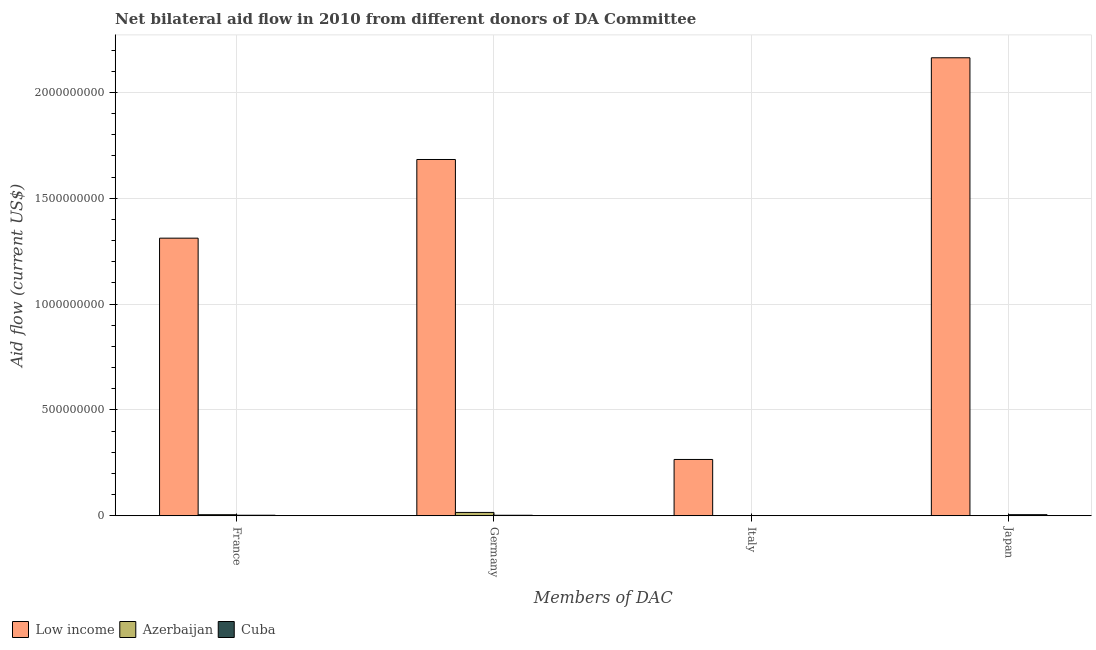How many groups of bars are there?
Your response must be concise. 4. Are the number of bars on each tick of the X-axis equal?
Provide a short and direct response. No. What is the amount of aid given by japan in Low income?
Keep it short and to the point. 2.16e+09. Across all countries, what is the maximum amount of aid given by japan?
Make the answer very short. 2.16e+09. Across all countries, what is the minimum amount of aid given by germany?
Give a very brief answer. 2.52e+06. In which country was the amount of aid given by italy maximum?
Your answer should be very brief. Low income. What is the total amount of aid given by germany in the graph?
Provide a short and direct response. 1.70e+09. What is the difference between the amount of aid given by germany in Low income and that in Azerbaijan?
Give a very brief answer. 1.67e+09. What is the difference between the amount of aid given by italy in Cuba and the amount of aid given by germany in Low income?
Provide a short and direct response. -1.68e+09. What is the average amount of aid given by japan per country?
Provide a succinct answer. 7.23e+08. What is the difference between the amount of aid given by italy and amount of aid given by japan in Cuba?
Provide a succinct answer. -4.27e+06. What is the ratio of the amount of aid given by italy in Cuba to that in Low income?
Keep it short and to the point. 0. Is the amount of aid given by germany in Cuba less than that in Azerbaijan?
Keep it short and to the point. Yes. What is the difference between the highest and the second highest amount of aid given by italy?
Keep it short and to the point. 2.65e+08. What is the difference between the highest and the lowest amount of aid given by japan?
Make the answer very short. 2.16e+09. In how many countries, is the amount of aid given by germany greater than the average amount of aid given by germany taken over all countries?
Make the answer very short. 1. Is the sum of the amount of aid given by germany in Low income and Cuba greater than the maximum amount of aid given by japan across all countries?
Give a very brief answer. No. Are all the bars in the graph horizontal?
Keep it short and to the point. No. How many countries are there in the graph?
Provide a succinct answer. 3. Does the graph contain any zero values?
Offer a terse response. Yes. How many legend labels are there?
Make the answer very short. 3. What is the title of the graph?
Ensure brevity in your answer.  Net bilateral aid flow in 2010 from different donors of DA Committee. What is the label or title of the X-axis?
Your answer should be very brief. Members of DAC. What is the Aid flow (current US$) of Low income in France?
Keep it short and to the point. 1.31e+09. What is the Aid flow (current US$) of Azerbaijan in France?
Give a very brief answer. 5.13e+06. What is the Aid flow (current US$) in Cuba in France?
Offer a very short reply. 2.68e+06. What is the Aid flow (current US$) of Low income in Germany?
Your answer should be very brief. 1.68e+09. What is the Aid flow (current US$) of Azerbaijan in Germany?
Ensure brevity in your answer.  1.59e+07. What is the Aid flow (current US$) in Cuba in Germany?
Provide a succinct answer. 2.52e+06. What is the Aid flow (current US$) in Low income in Italy?
Offer a very short reply. 2.66e+08. What is the Aid flow (current US$) in Cuba in Italy?
Offer a terse response. 8.90e+05. What is the Aid flow (current US$) in Low income in Japan?
Your answer should be very brief. 2.16e+09. What is the Aid flow (current US$) in Cuba in Japan?
Your answer should be compact. 5.16e+06. Across all Members of DAC, what is the maximum Aid flow (current US$) in Low income?
Your response must be concise. 2.16e+09. Across all Members of DAC, what is the maximum Aid flow (current US$) of Azerbaijan?
Your answer should be compact. 1.59e+07. Across all Members of DAC, what is the maximum Aid flow (current US$) of Cuba?
Your answer should be very brief. 5.16e+06. Across all Members of DAC, what is the minimum Aid flow (current US$) of Low income?
Ensure brevity in your answer.  2.66e+08. Across all Members of DAC, what is the minimum Aid flow (current US$) of Azerbaijan?
Provide a short and direct response. 0. Across all Members of DAC, what is the minimum Aid flow (current US$) in Cuba?
Provide a succinct answer. 8.90e+05. What is the total Aid flow (current US$) in Low income in the graph?
Your answer should be compact. 5.42e+09. What is the total Aid flow (current US$) of Azerbaijan in the graph?
Offer a very short reply. 2.10e+07. What is the total Aid flow (current US$) in Cuba in the graph?
Ensure brevity in your answer.  1.12e+07. What is the difference between the Aid flow (current US$) of Low income in France and that in Germany?
Your answer should be compact. -3.72e+08. What is the difference between the Aid flow (current US$) of Azerbaijan in France and that in Germany?
Your answer should be compact. -1.07e+07. What is the difference between the Aid flow (current US$) of Cuba in France and that in Germany?
Provide a succinct answer. 1.60e+05. What is the difference between the Aid flow (current US$) of Low income in France and that in Italy?
Your answer should be very brief. 1.05e+09. What is the difference between the Aid flow (current US$) of Azerbaijan in France and that in Italy?
Make the answer very short. 5.12e+06. What is the difference between the Aid flow (current US$) in Cuba in France and that in Italy?
Make the answer very short. 1.79e+06. What is the difference between the Aid flow (current US$) in Low income in France and that in Japan?
Your response must be concise. -8.52e+08. What is the difference between the Aid flow (current US$) of Cuba in France and that in Japan?
Your response must be concise. -2.48e+06. What is the difference between the Aid flow (current US$) of Low income in Germany and that in Italy?
Provide a succinct answer. 1.42e+09. What is the difference between the Aid flow (current US$) in Azerbaijan in Germany and that in Italy?
Provide a succinct answer. 1.59e+07. What is the difference between the Aid flow (current US$) of Cuba in Germany and that in Italy?
Your answer should be very brief. 1.63e+06. What is the difference between the Aid flow (current US$) in Low income in Germany and that in Japan?
Your answer should be compact. -4.81e+08. What is the difference between the Aid flow (current US$) in Cuba in Germany and that in Japan?
Offer a very short reply. -2.64e+06. What is the difference between the Aid flow (current US$) in Low income in Italy and that in Japan?
Keep it short and to the point. -1.90e+09. What is the difference between the Aid flow (current US$) in Cuba in Italy and that in Japan?
Offer a terse response. -4.27e+06. What is the difference between the Aid flow (current US$) in Low income in France and the Aid flow (current US$) in Azerbaijan in Germany?
Offer a terse response. 1.30e+09. What is the difference between the Aid flow (current US$) of Low income in France and the Aid flow (current US$) of Cuba in Germany?
Give a very brief answer. 1.31e+09. What is the difference between the Aid flow (current US$) of Azerbaijan in France and the Aid flow (current US$) of Cuba in Germany?
Ensure brevity in your answer.  2.61e+06. What is the difference between the Aid flow (current US$) in Low income in France and the Aid flow (current US$) in Azerbaijan in Italy?
Your response must be concise. 1.31e+09. What is the difference between the Aid flow (current US$) in Low income in France and the Aid flow (current US$) in Cuba in Italy?
Keep it short and to the point. 1.31e+09. What is the difference between the Aid flow (current US$) of Azerbaijan in France and the Aid flow (current US$) of Cuba in Italy?
Keep it short and to the point. 4.24e+06. What is the difference between the Aid flow (current US$) of Low income in France and the Aid flow (current US$) of Cuba in Japan?
Your answer should be very brief. 1.31e+09. What is the difference between the Aid flow (current US$) of Azerbaijan in France and the Aid flow (current US$) of Cuba in Japan?
Give a very brief answer. -3.00e+04. What is the difference between the Aid flow (current US$) in Low income in Germany and the Aid flow (current US$) in Azerbaijan in Italy?
Offer a terse response. 1.68e+09. What is the difference between the Aid flow (current US$) in Low income in Germany and the Aid flow (current US$) in Cuba in Italy?
Your answer should be compact. 1.68e+09. What is the difference between the Aid flow (current US$) of Azerbaijan in Germany and the Aid flow (current US$) of Cuba in Italy?
Ensure brevity in your answer.  1.50e+07. What is the difference between the Aid flow (current US$) in Low income in Germany and the Aid flow (current US$) in Cuba in Japan?
Your response must be concise. 1.68e+09. What is the difference between the Aid flow (current US$) in Azerbaijan in Germany and the Aid flow (current US$) in Cuba in Japan?
Provide a succinct answer. 1.07e+07. What is the difference between the Aid flow (current US$) of Low income in Italy and the Aid flow (current US$) of Cuba in Japan?
Your answer should be compact. 2.61e+08. What is the difference between the Aid flow (current US$) of Azerbaijan in Italy and the Aid flow (current US$) of Cuba in Japan?
Provide a short and direct response. -5.15e+06. What is the average Aid flow (current US$) in Low income per Members of DAC?
Your answer should be compact. 1.36e+09. What is the average Aid flow (current US$) of Azerbaijan per Members of DAC?
Offer a terse response. 5.25e+06. What is the average Aid flow (current US$) of Cuba per Members of DAC?
Offer a terse response. 2.81e+06. What is the difference between the Aid flow (current US$) in Low income and Aid flow (current US$) in Azerbaijan in France?
Provide a short and direct response. 1.31e+09. What is the difference between the Aid flow (current US$) in Low income and Aid flow (current US$) in Cuba in France?
Offer a very short reply. 1.31e+09. What is the difference between the Aid flow (current US$) in Azerbaijan and Aid flow (current US$) in Cuba in France?
Provide a succinct answer. 2.45e+06. What is the difference between the Aid flow (current US$) in Low income and Aid flow (current US$) in Azerbaijan in Germany?
Offer a very short reply. 1.67e+09. What is the difference between the Aid flow (current US$) of Low income and Aid flow (current US$) of Cuba in Germany?
Offer a terse response. 1.68e+09. What is the difference between the Aid flow (current US$) in Azerbaijan and Aid flow (current US$) in Cuba in Germany?
Your response must be concise. 1.34e+07. What is the difference between the Aid flow (current US$) in Low income and Aid flow (current US$) in Azerbaijan in Italy?
Provide a succinct answer. 2.66e+08. What is the difference between the Aid flow (current US$) of Low income and Aid flow (current US$) of Cuba in Italy?
Offer a very short reply. 2.65e+08. What is the difference between the Aid flow (current US$) in Azerbaijan and Aid flow (current US$) in Cuba in Italy?
Give a very brief answer. -8.80e+05. What is the difference between the Aid flow (current US$) of Low income and Aid flow (current US$) of Cuba in Japan?
Keep it short and to the point. 2.16e+09. What is the ratio of the Aid flow (current US$) of Low income in France to that in Germany?
Your answer should be compact. 0.78. What is the ratio of the Aid flow (current US$) of Azerbaijan in France to that in Germany?
Your response must be concise. 0.32. What is the ratio of the Aid flow (current US$) in Cuba in France to that in Germany?
Offer a very short reply. 1.06. What is the ratio of the Aid flow (current US$) of Low income in France to that in Italy?
Provide a short and direct response. 4.93. What is the ratio of the Aid flow (current US$) in Azerbaijan in France to that in Italy?
Ensure brevity in your answer.  513. What is the ratio of the Aid flow (current US$) of Cuba in France to that in Italy?
Your answer should be very brief. 3.01. What is the ratio of the Aid flow (current US$) of Low income in France to that in Japan?
Provide a short and direct response. 0.61. What is the ratio of the Aid flow (current US$) of Cuba in France to that in Japan?
Give a very brief answer. 0.52. What is the ratio of the Aid flow (current US$) of Low income in Germany to that in Italy?
Make the answer very short. 6.33. What is the ratio of the Aid flow (current US$) in Azerbaijan in Germany to that in Italy?
Your response must be concise. 1587. What is the ratio of the Aid flow (current US$) in Cuba in Germany to that in Italy?
Your response must be concise. 2.83. What is the ratio of the Aid flow (current US$) in Low income in Germany to that in Japan?
Provide a succinct answer. 0.78. What is the ratio of the Aid flow (current US$) in Cuba in Germany to that in Japan?
Offer a very short reply. 0.49. What is the ratio of the Aid flow (current US$) in Low income in Italy to that in Japan?
Your answer should be compact. 0.12. What is the ratio of the Aid flow (current US$) in Cuba in Italy to that in Japan?
Ensure brevity in your answer.  0.17. What is the difference between the highest and the second highest Aid flow (current US$) in Low income?
Provide a short and direct response. 4.81e+08. What is the difference between the highest and the second highest Aid flow (current US$) of Azerbaijan?
Keep it short and to the point. 1.07e+07. What is the difference between the highest and the second highest Aid flow (current US$) of Cuba?
Make the answer very short. 2.48e+06. What is the difference between the highest and the lowest Aid flow (current US$) in Low income?
Give a very brief answer. 1.90e+09. What is the difference between the highest and the lowest Aid flow (current US$) in Azerbaijan?
Your answer should be very brief. 1.59e+07. What is the difference between the highest and the lowest Aid flow (current US$) of Cuba?
Make the answer very short. 4.27e+06. 